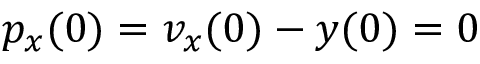Convert formula to latex. <formula><loc_0><loc_0><loc_500><loc_500>p _ { x } ( 0 ) = v _ { x } ( 0 ) - y ( 0 ) = 0</formula> 